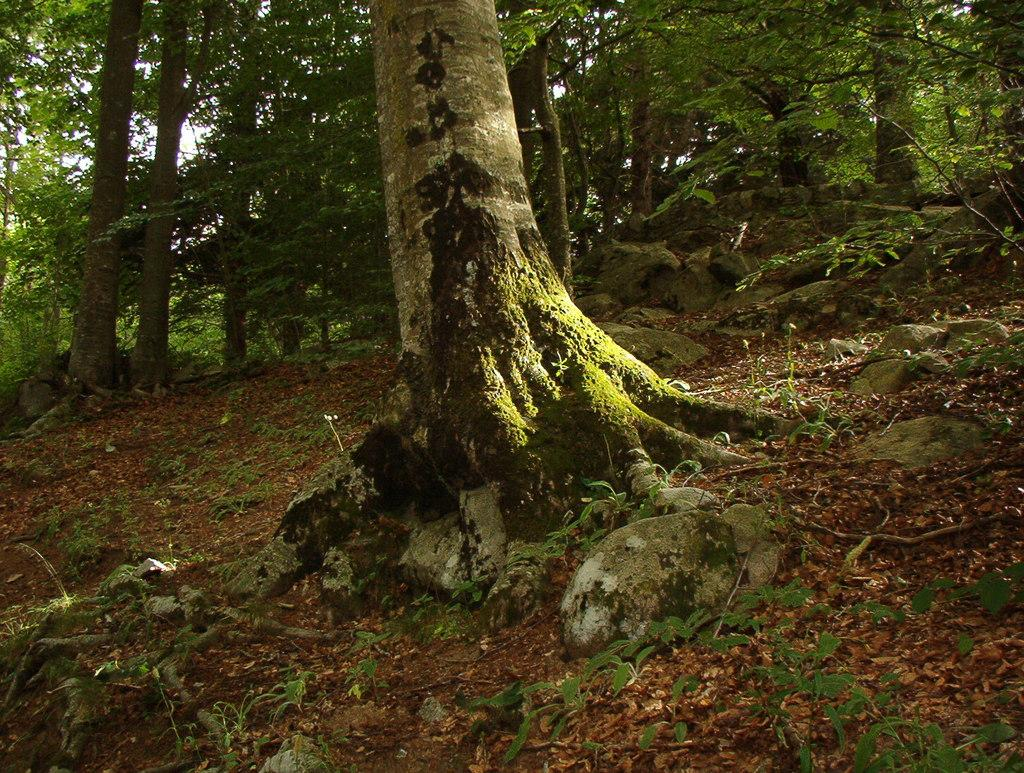What type of vegetation can be seen in the image? There are trees and plants in the image. What covers some parts of the ground in the image? Some parts of the ground are covered with grass. What other objects can be seen on the ground in the image? Stones are present in the image. Where is the kettle located in the image? There is no kettle present in the image. Can you describe the temperature of the frog in the image? There is no frog present in the image, so it is not possible to describe its temperature. 